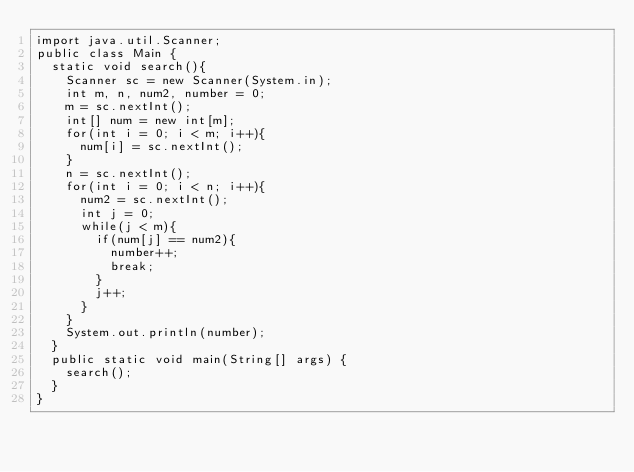<code> <loc_0><loc_0><loc_500><loc_500><_Java_>import java.util.Scanner;
public class Main {
	static void search(){
		Scanner sc = new Scanner(System.in);
		int m, n, num2, number = 0;
		m = sc.nextInt();
		int[] num = new int[m];
		for(int i = 0; i < m; i++){
			num[i] = sc.nextInt();
		}
		n = sc.nextInt();
		for(int i = 0; i < n; i++){
			num2 = sc.nextInt();
			int j = 0;
			while(j < m){
				if(num[j] == num2){
					number++;
					break;
				}
				j++;
			}
		}
		System.out.println(number);
	}
	public static void main(String[] args) {
		search();
	}
}</code> 